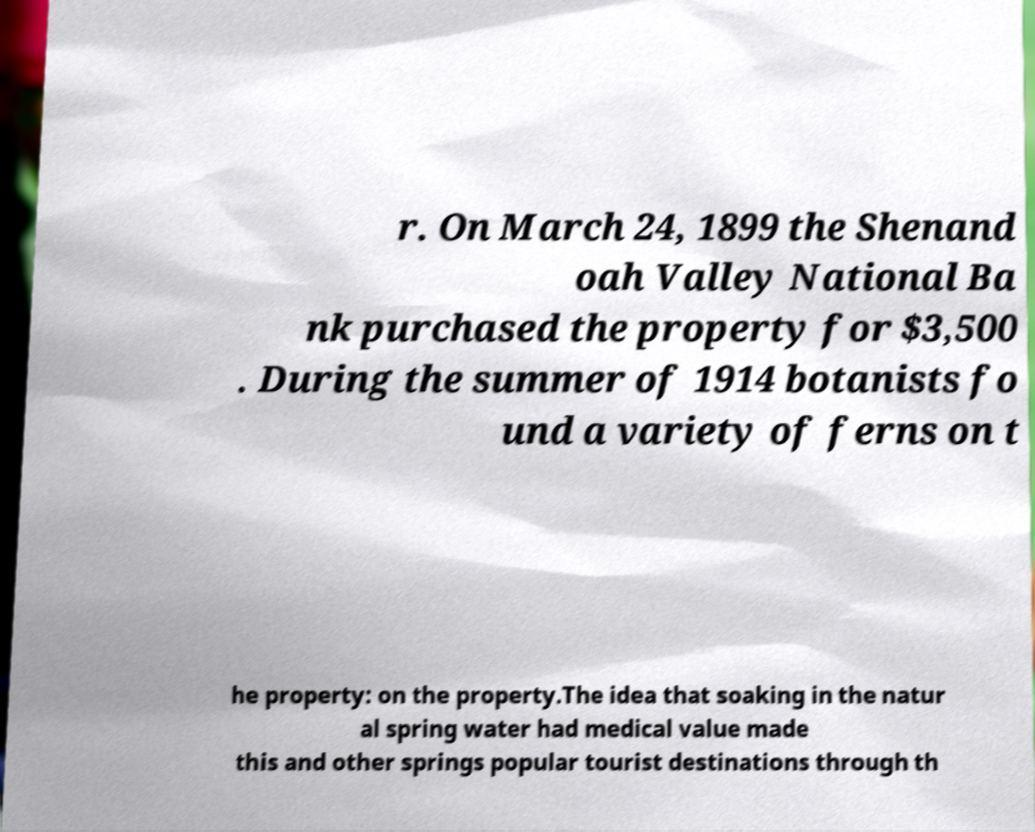Can you accurately transcribe the text from the provided image for me? r. On March 24, 1899 the Shenand oah Valley National Ba nk purchased the property for $3,500 . During the summer of 1914 botanists fo und a variety of ferns on t he property: on the property.The idea that soaking in the natur al spring water had medical value made this and other springs popular tourist destinations through th 